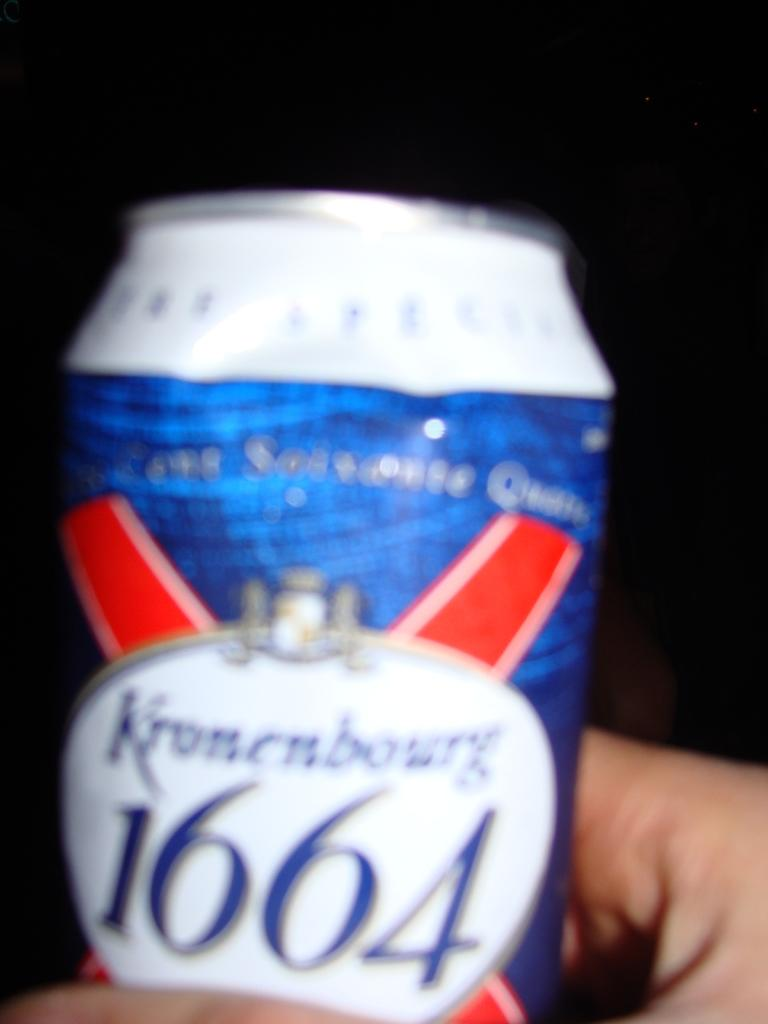Provide a one-sentence caption for the provided image. Blue, red, and white can with 1664 wrote on the front. 